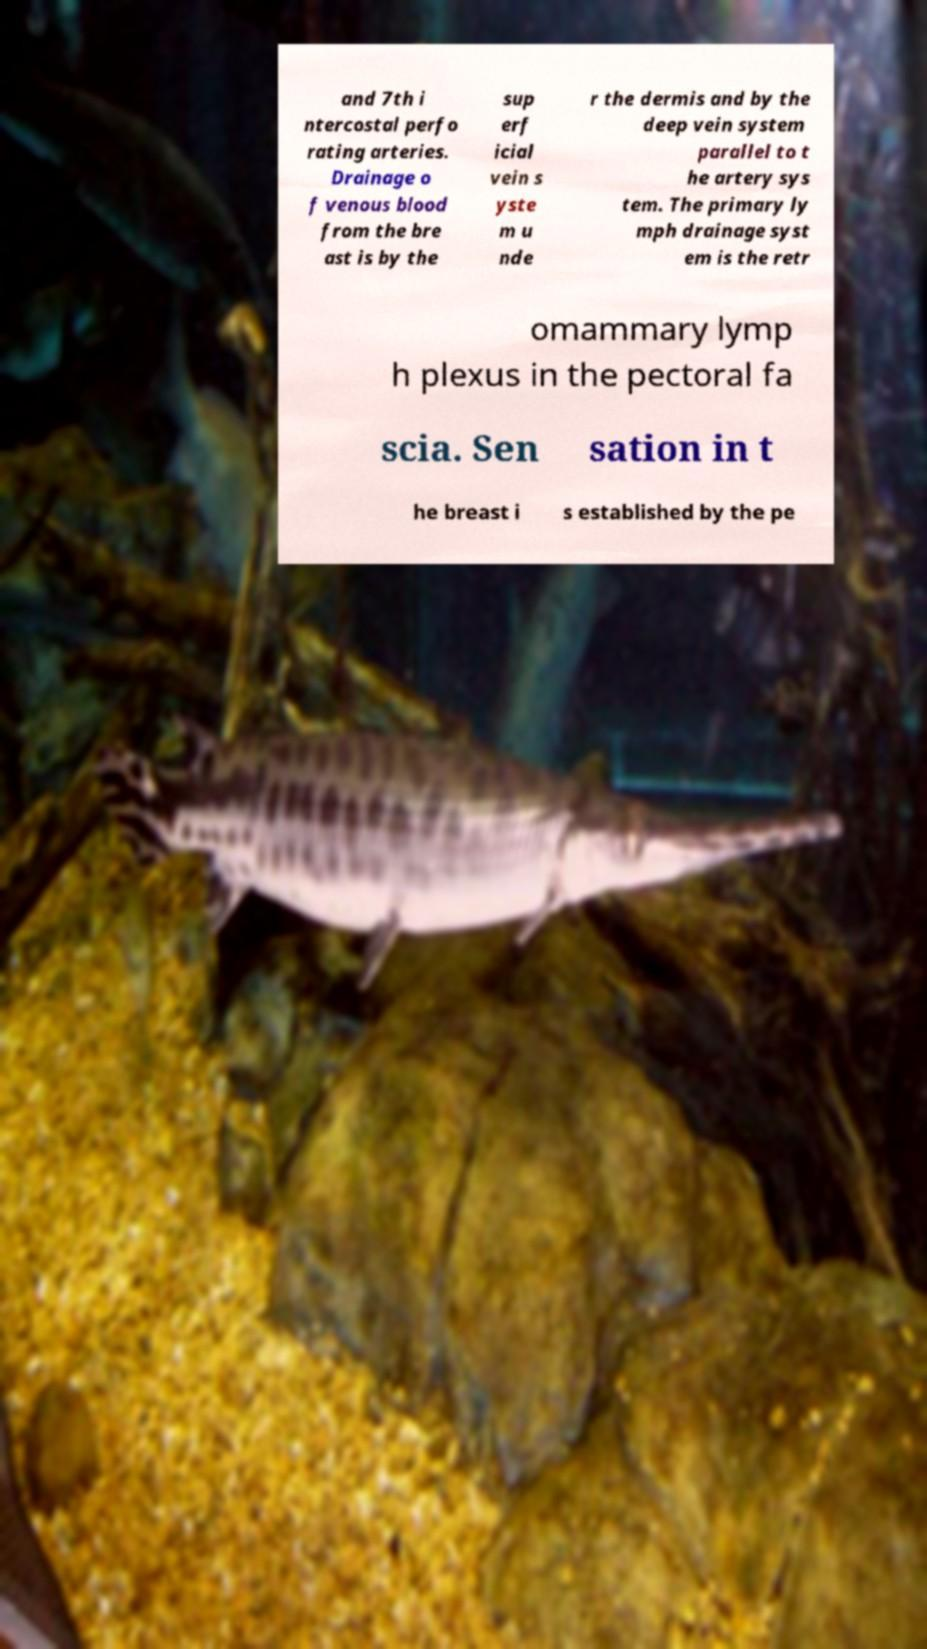I need the written content from this picture converted into text. Can you do that? and 7th i ntercostal perfo rating arteries. Drainage o f venous blood from the bre ast is by the sup erf icial vein s yste m u nde r the dermis and by the deep vein system parallel to t he artery sys tem. The primary ly mph drainage syst em is the retr omammary lymp h plexus in the pectoral fa scia. Sen sation in t he breast i s established by the pe 